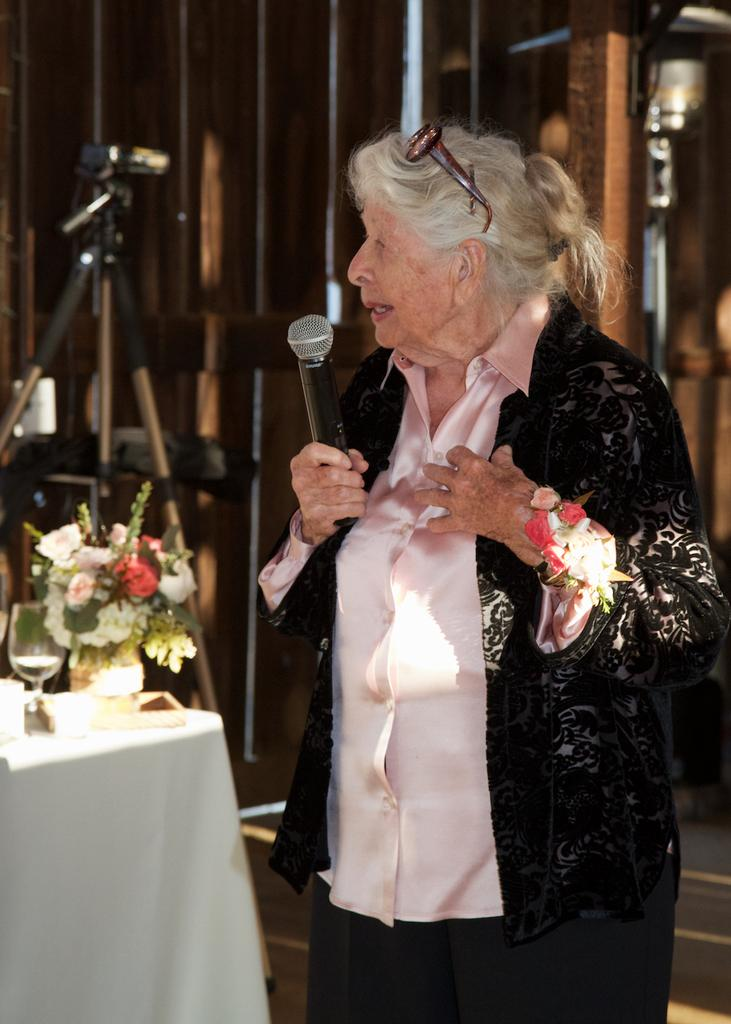Who is the main subject in the image? There is a woman standing in the middle of the image. What is the woman holding in the image? The woman is holding a microphone. What can be seen in the bottom left side of the image? There is a table in the bottom left side of the image. What items are on the table in the image? There is a glass and a flower pot on the table. How many spiders are crawling on the woman's arm in the image? There are no spiders visible on the woman's arm in the image. What is the woman's reaction to the surprise in the image? There is no surprise depicted in the image, so it is not possible to determine the woman's reaction. 